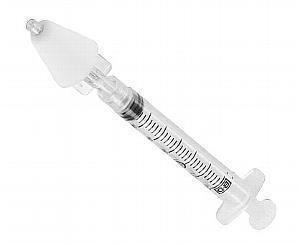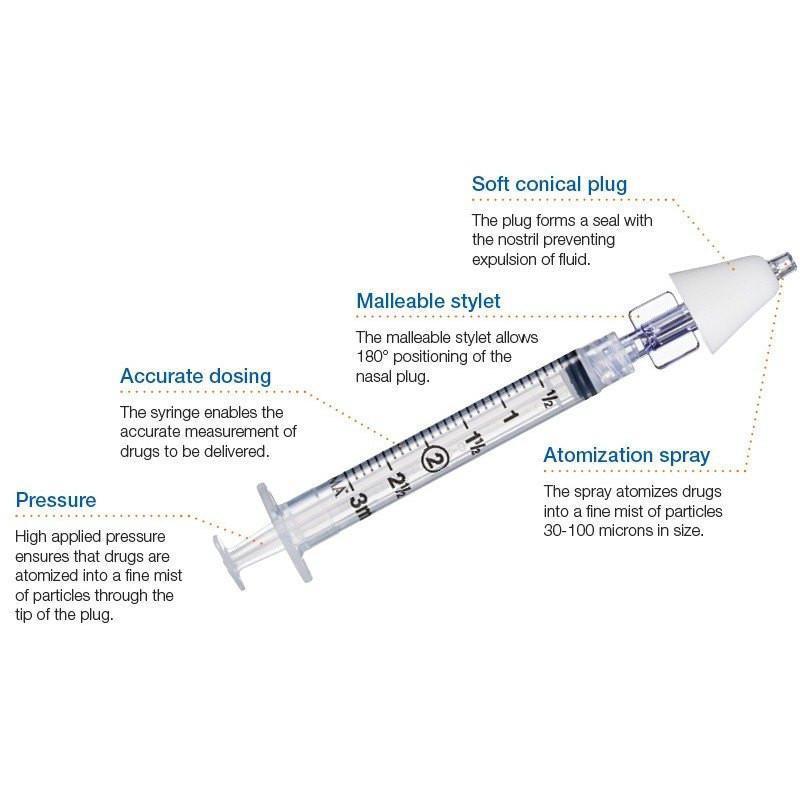The first image is the image on the left, the second image is the image on the right. Considering the images on both sides, is "There is at least one gloved hand in the picture." valid? Answer yes or no. No. 